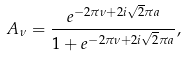Convert formula to latex. <formula><loc_0><loc_0><loc_500><loc_500>A _ { \nu } = \frac { e ^ { - 2 \pi \nu + 2 i \sqrt { 2 } \pi a } } { 1 + e ^ { - 2 \pi \nu + 2 i \sqrt { 2 } \pi a } } ,</formula> 